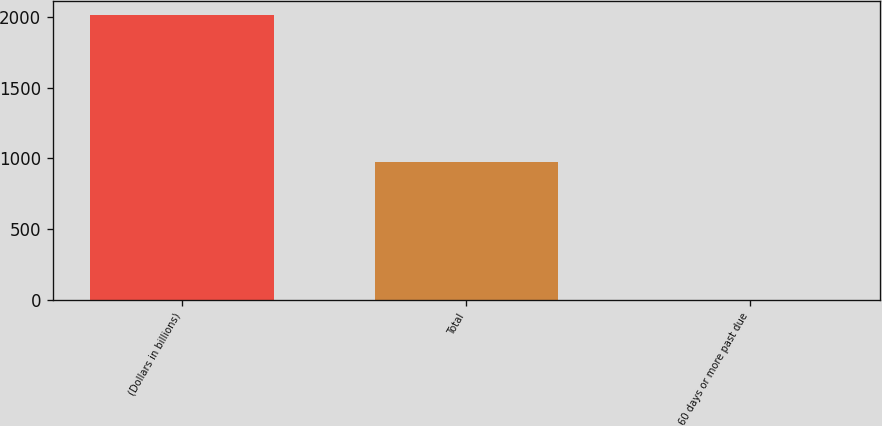Convert chart to OTSL. <chart><loc_0><loc_0><loc_500><loc_500><bar_chart><fcel>(Dollars in billions)<fcel>Total<fcel>60 days or more past due<nl><fcel>2010<fcel>977<fcel>1<nl></chart> 